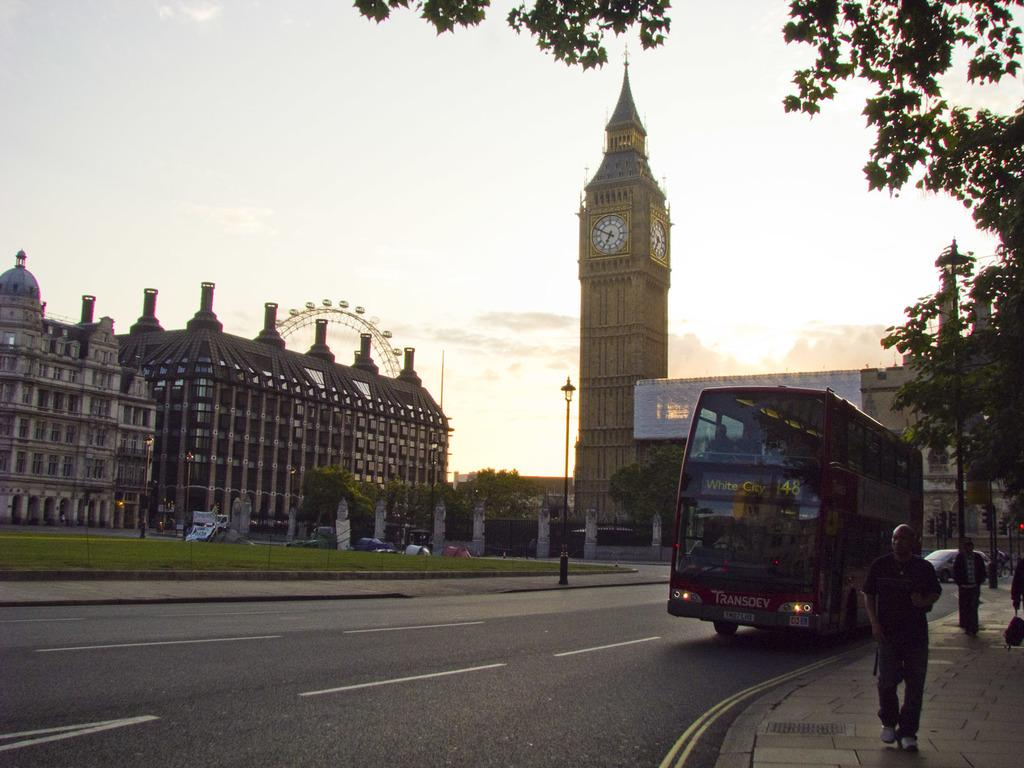<image>
Share a concise interpretation of the image provided. The bus running route 48 is headed to White City. 